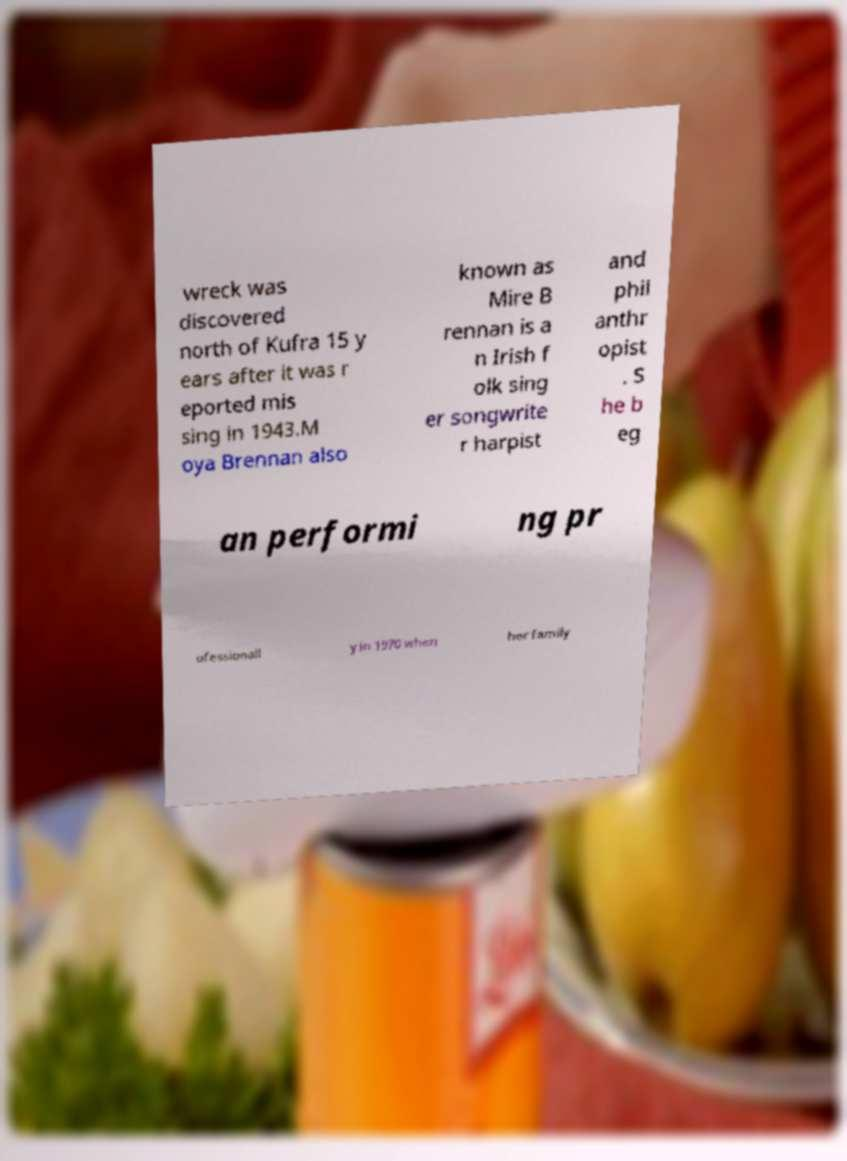There's text embedded in this image that I need extracted. Can you transcribe it verbatim? wreck was discovered north of Kufra 15 y ears after it was r eported mis sing in 1943.M oya Brennan also known as Mire B rennan is a n Irish f olk sing er songwrite r harpist and phil anthr opist . S he b eg an performi ng pr ofessionall y in 1970 when her family 